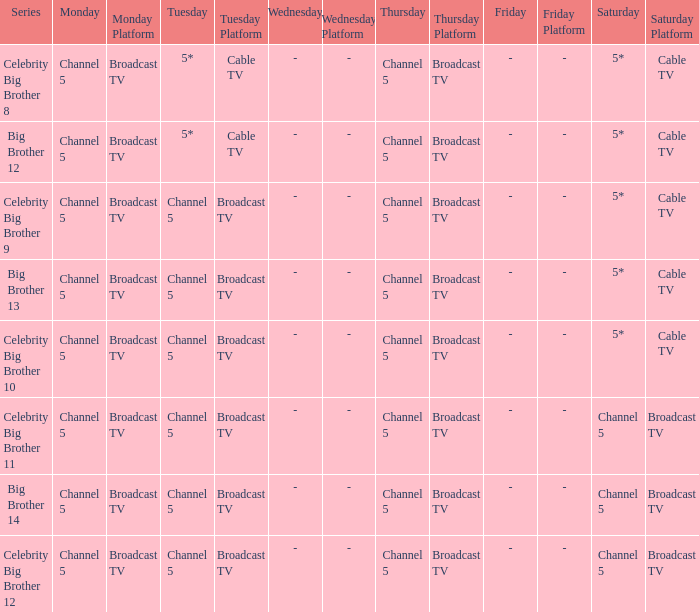Which Tuesday does big brother 12 air? 5*. 